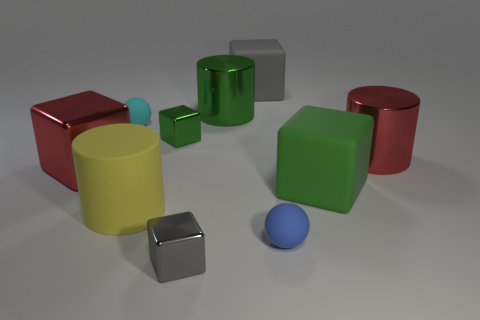Subtract 3 blocks. How many blocks are left? 2 Subtract all red cubes. How many cubes are left? 4 Subtract all gray blocks. How many blocks are left? 3 Subtract all cyan blocks. Subtract all cyan cylinders. How many blocks are left? 5 Add 5 small blue balls. How many small blue balls exist? 6 Subtract 0 brown cylinders. How many objects are left? 10 Subtract all balls. How many objects are left? 8 Subtract all big balls. Subtract all large things. How many objects are left? 4 Add 4 big cubes. How many big cubes are left? 7 